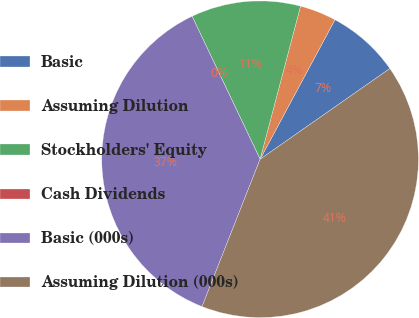<chart> <loc_0><loc_0><loc_500><loc_500><pie_chart><fcel>Basic<fcel>Assuming Dilution<fcel>Stockholders' Equity<fcel>Cash Dividends<fcel>Basic (000s)<fcel>Assuming Dilution (000s)<nl><fcel>7.45%<fcel>3.73%<fcel>11.18%<fcel>0.0%<fcel>36.96%<fcel>40.69%<nl></chart> 